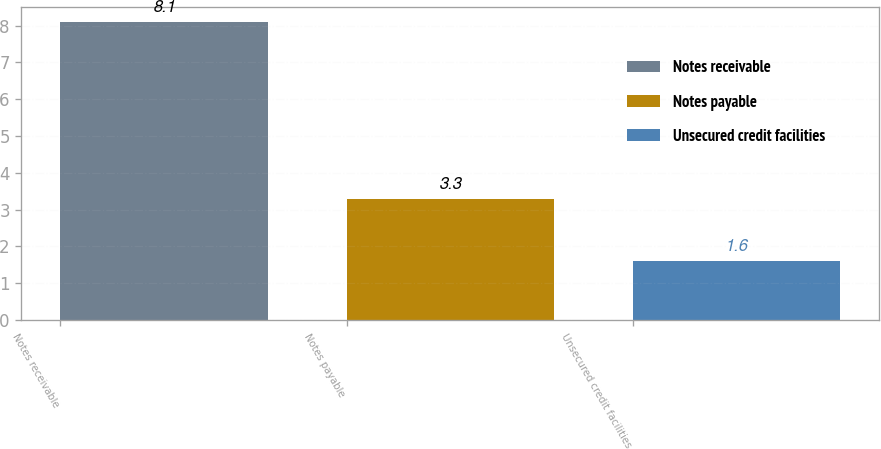<chart> <loc_0><loc_0><loc_500><loc_500><bar_chart><fcel>Notes receivable<fcel>Notes payable<fcel>Unsecured credit facilities<nl><fcel>8.1<fcel>3.3<fcel>1.6<nl></chart> 